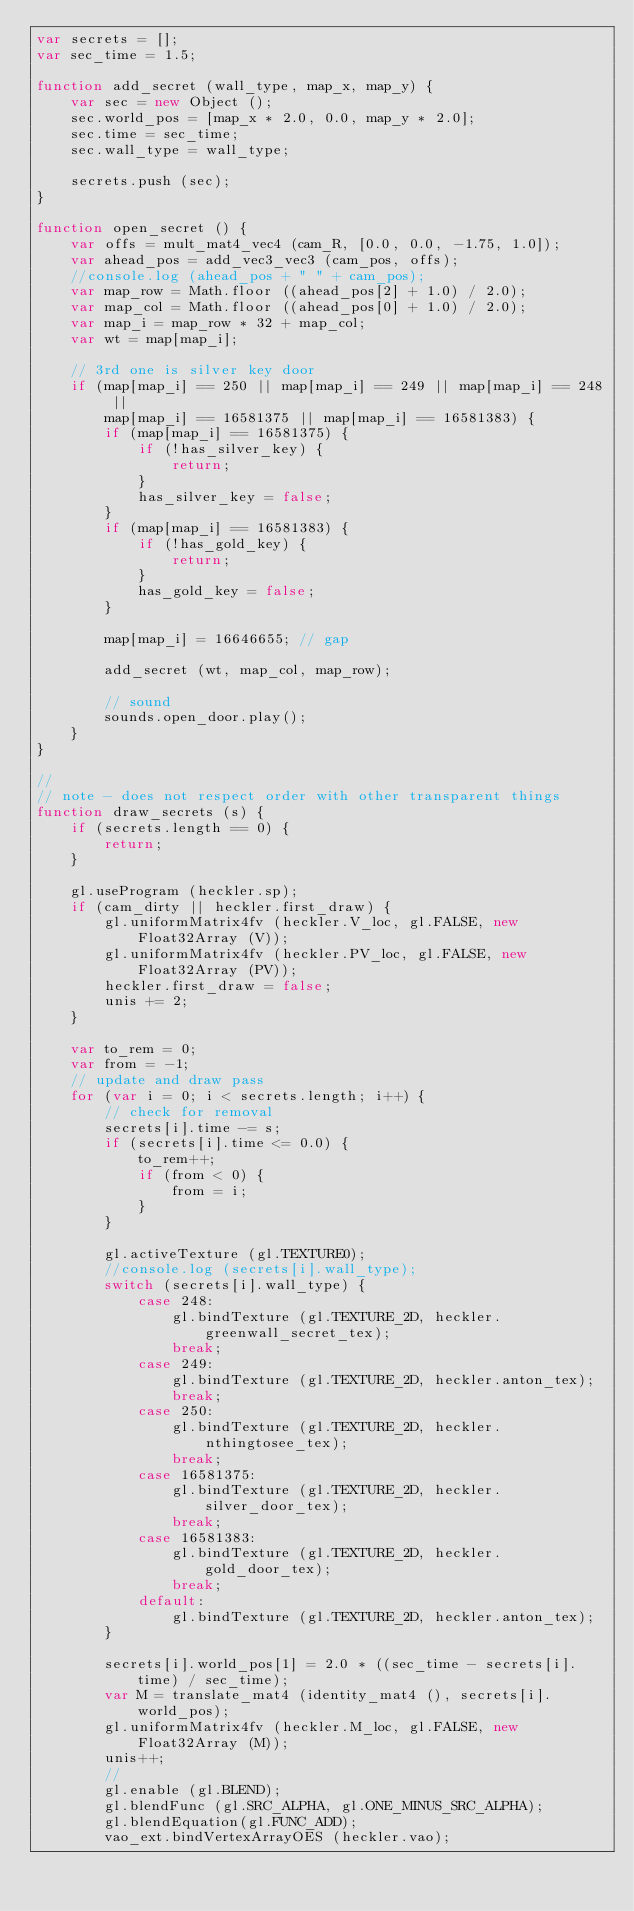<code> <loc_0><loc_0><loc_500><loc_500><_JavaScript_>var secrets = [];
var sec_time = 1.5;

function add_secret (wall_type, map_x, map_y) {
	var sec = new Object ();
	sec.world_pos = [map_x * 2.0, 0.0, map_y * 2.0];
	sec.time = sec_time;
	sec.wall_type = wall_type;
	
	secrets.push (sec);
}

function open_secret () {
	var offs = mult_mat4_vec4 (cam_R, [0.0, 0.0, -1.75, 1.0]);
	var ahead_pos = add_vec3_vec3 (cam_pos, offs);
	//console.log (ahead_pos + " " + cam_pos);
	var map_row = Math.floor ((ahead_pos[2] + 1.0) / 2.0);
	var map_col = Math.floor ((ahead_pos[0] + 1.0) / 2.0);
	var map_i = map_row * 32 + map_col;
	var wt = map[map_i];
	
	// 3rd one is silver key door
	if (map[map_i] == 250 || map[map_i] == 249 || map[map_i] == 248 ||
		map[map_i] == 16581375 || map[map_i] == 16581383) {
		if (map[map_i] == 16581375) {
			if (!has_silver_key) {
				return;
			}
			has_silver_key = false;
		}
		if (map[map_i] == 16581383) {
			if (!has_gold_key) {
				return;
			}
			has_gold_key = false;
		}
	
		map[map_i] = 16646655; // gap
		
		add_secret (wt, map_col, map_row);
		
		// sound
		sounds.open_door.play();
	}
}

//
// note - does not respect order with other transparent things
function draw_secrets (s) {
	if (secrets.length == 0) {
		return;
	}
	
	gl.useProgram (heckler.sp);
	if (cam_dirty || heckler.first_draw) {
		gl.uniformMatrix4fv (heckler.V_loc, gl.FALSE, new Float32Array (V));
		gl.uniformMatrix4fv (heckler.PV_loc, gl.FALSE, new Float32Array (PV));
		heckler.first_draw = false;
		unis += 2;
	}

	var to_rem = 0;
	var from = -1;
	// update and draw pass
	for (var i = 0; i < secrets.length; i++) {
		// check for removal
		secrets[i].time -= s;
		if (secrets[i].time <= 0.0) {
			to_rem++;
			if (from < 0) {
				from = i;
			}
		}
		
		gl.activeTexture (gl.TEXTURE0);
		//console.log (secrets[i].wall_type);
		switch (secrets[i].wall_type) {
			case 248:
				gl.bindTexture (gl.TEXTURE_2D, heckler.greenwall_secret_tex);
				break;
			case 249:
				gl.bindTexture (gl.TEXTURE_2D, heckler.anton_tex);
				break;
			case 250:
				gl.bindTexture (gl.TEXTURE_2D, heckler.nthingtosee_tex);
				break;
			case 16581375:
				gl.bindTexture (gl.TEXTURE_2D, heckler.silver_door_tex);
				break;
			case 16581383:
				gl.bindTexture (gl.TEXTURE_2D, heckler.gold_door_tex);
				break;
			default:
				gl.bindTexture (gl.TEXTURE_2D, heckler.anton_tex);
		}
		
		secrets[i].world_pos[1] = 2.0 * ((sec_time - secrets[i].time) / sec_time);
		var M = translate_mat4 (identity_mat4 (), secrets[i].world_pos);
		gl.uniformMatrix4fv (heckler.M_loc, gl.FALSE, new Float32Array (M));
		unis++;
		//
		gl.enable (gl.BLEND);
		gl.blendFunc (gl.SRC_ALPHA, gl.ONE_MINUS_SRC_ALPHA);
		gl.blendEquation(gl.FUNC_ADD);
		vao_ext.bindVertexArrayOES (heckler.vao);</code> 